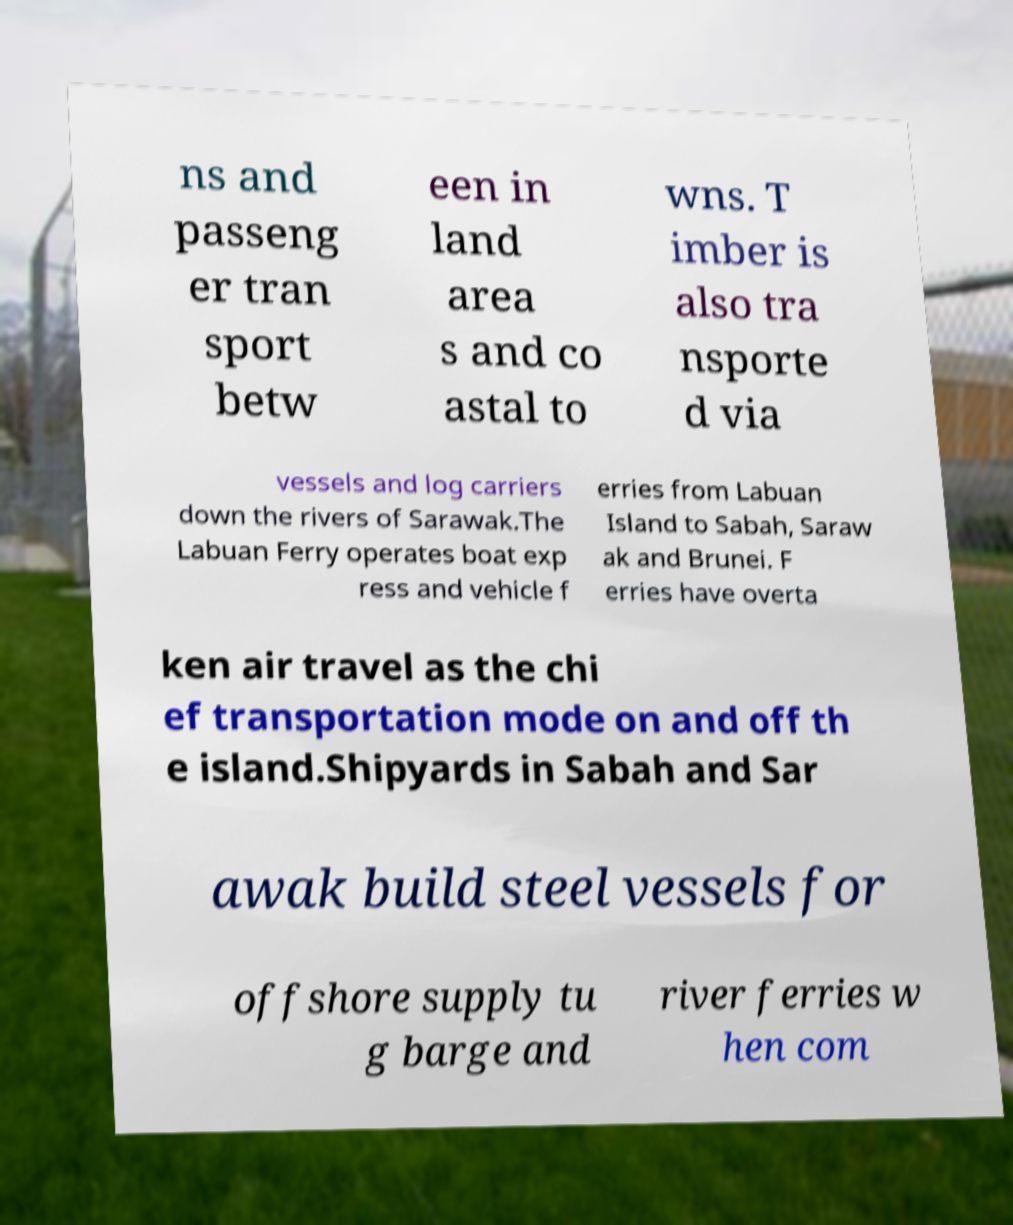I need the written content from this picture converted into text. Can you do that? ns and passeng er tran sport betw een in land area s and co astal to wns. T imber is also tra nsporte d via vessels and log carriers down the rivers of Sarawak.The Labuan Ferry operates boat exp ress and vehicle f erries from Labuan Island to Sabah, Saraw ak and Brunei. F erries have overta ken air travel as the chi ef transportation mode on and off th e island.Shipyards in Sabah and Sar awak build steel vessels for offshore supply tu g barge and river ferries w hen com 